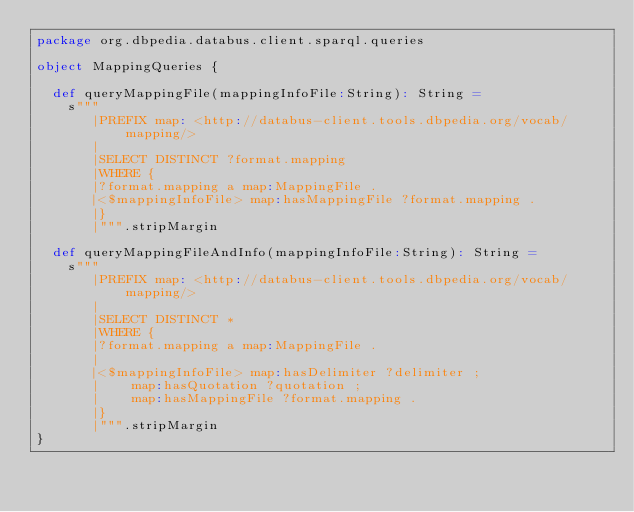Convert code to text. <code><loc_0><loc_0><loc_500><loc_500><_Scala_>package org.dbpedia.databus.client.sparql.queries

object MappingQueries {

  def queryMappingFile(mappingInfoFile:String): String =
    s"""
       |PREFIX map: <http://databus-client.tools.dbpedia.org/vocab/mapping/>
       |
       |SELECT DISTINCT ?format.mapping
       |WHERE {
       |?format.mapping a map:MappingFile .
       |<$mappingInfoFile> map:hasMappingFile ?format.mapping .
       |}
       |""".stripMargin

  def queryMappingFileAndInfo(mappingInfoFile:String): String =
    s"""
       |PREFIX map: <http://databus-client.tools.dbpedia.org/vocab/mapping/>
       |
       |SELECT DISTINCT *
       |WHERE {
       |?format.mapping a map:MappingFile .
       |
       |<$mappingInfoFile> map:hasDelimiter ?delimiter ;
       |	  map:hasQuotation ?quotation ;
       |    map:hasMappingFile ?format.mapping .
       |}
       |""".stripMargin
}
</code> 